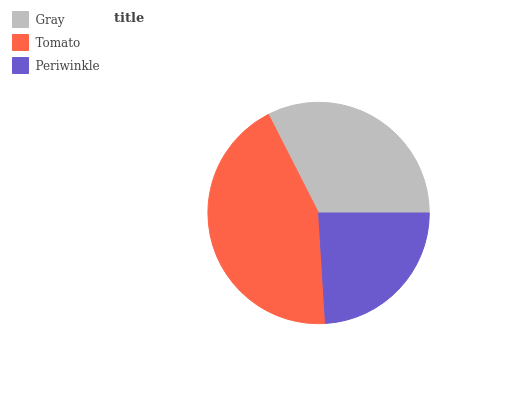Is Periwinkle the minimum?
Answer yes or no. Yes. Is Tomato the maximum?
Answer yes or no. Yes. Is Tomato the minimum?
Answer yes or no. No. Is Periwinkle the maximum?
Answer yes or no. No. Is Tomato greater than Periwinkle?
Answer yes or no. Yes. Is Periwinkle less than Tomato?
Answer yes or no. Yes. Is Periwinkle greater than Tomato?
Answer yes or no. No. Is Tomato less than Periwinkle?
Answer yes or no. No. Is Gray the high median?
Answer yes or no. Yes. Is Gray the low median?
Answer yes or no. Yes. Is Periwinkle the high median?
Answer yes or no. No. Is Tomato the low median?
Answer yes or no. No. 